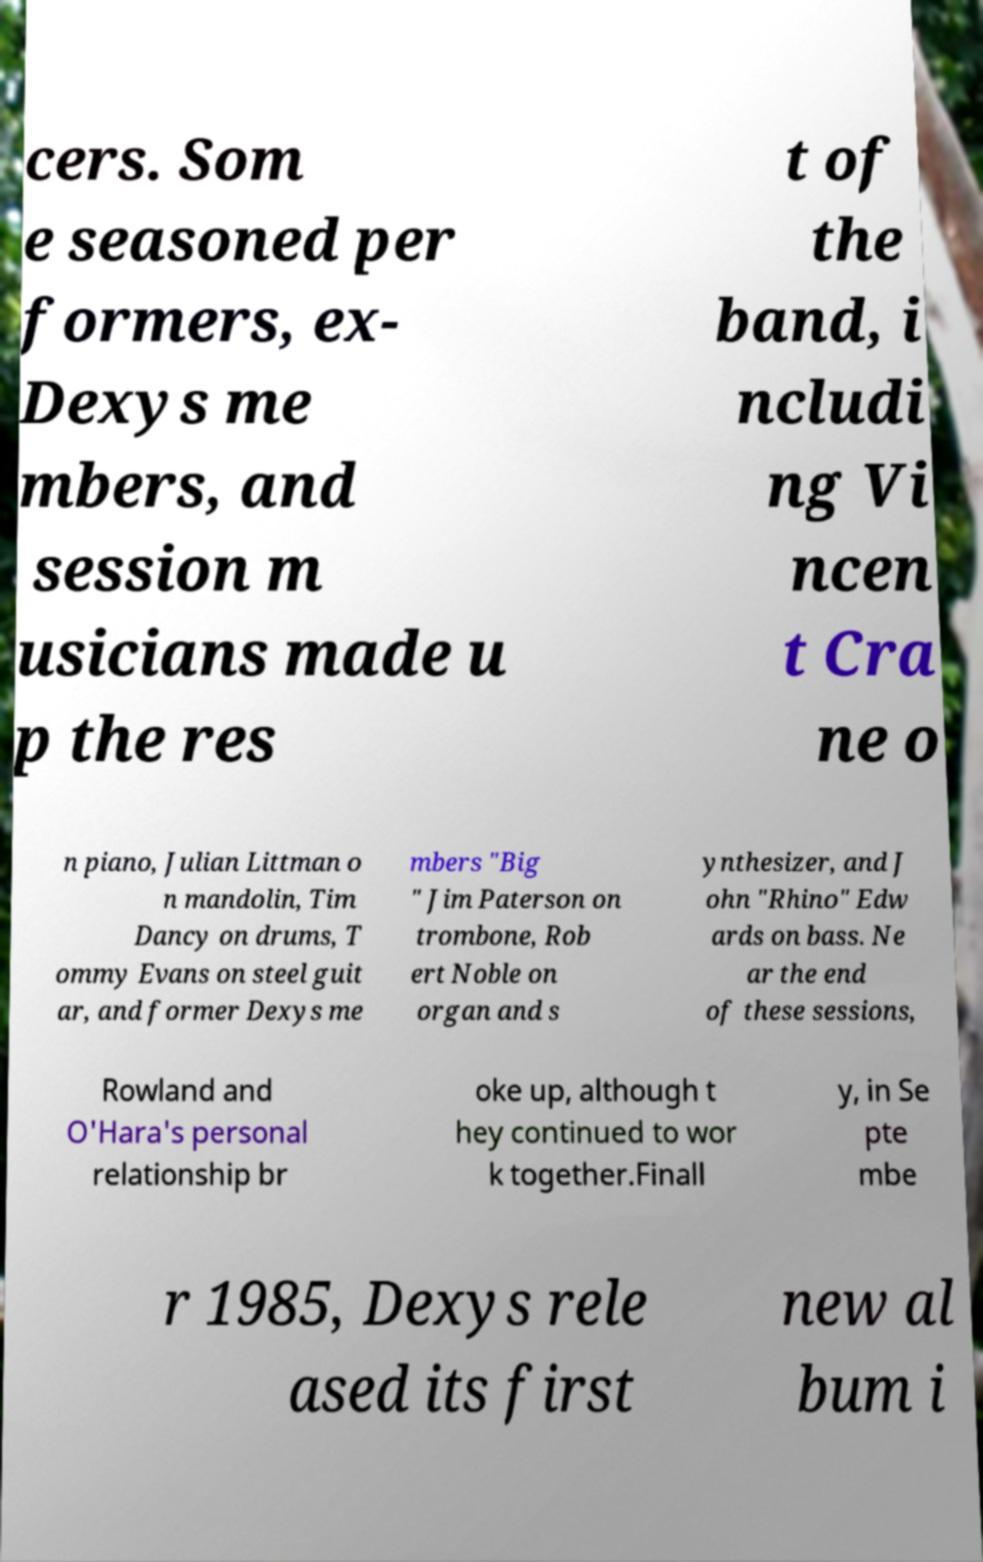Please identify and transcribe the text found in this image. cers. Som e seasoned per formers, ex- Dexys me mbers, and session m usicians made u p the res t of the band, i ncludi ng Vi ncen t Cra ne o n piano, Julian Littman o n mandolin, Tim Dancy on drums, T ommy Evans on steel guit ar, and former Dexys me mbers "Big " Jim Paterson on trombone, Rob ert Noble on organ and s ynthesizer, and J ohn "Rhino" Edw ards on bass. Ne ar the end of these sessions, Rowland and O'Hara's personal relationship br oke up, although t hey continued to wor k together.Finall y, in Se pte mbe r 1985, Dexys rele ased its first new al bum i 